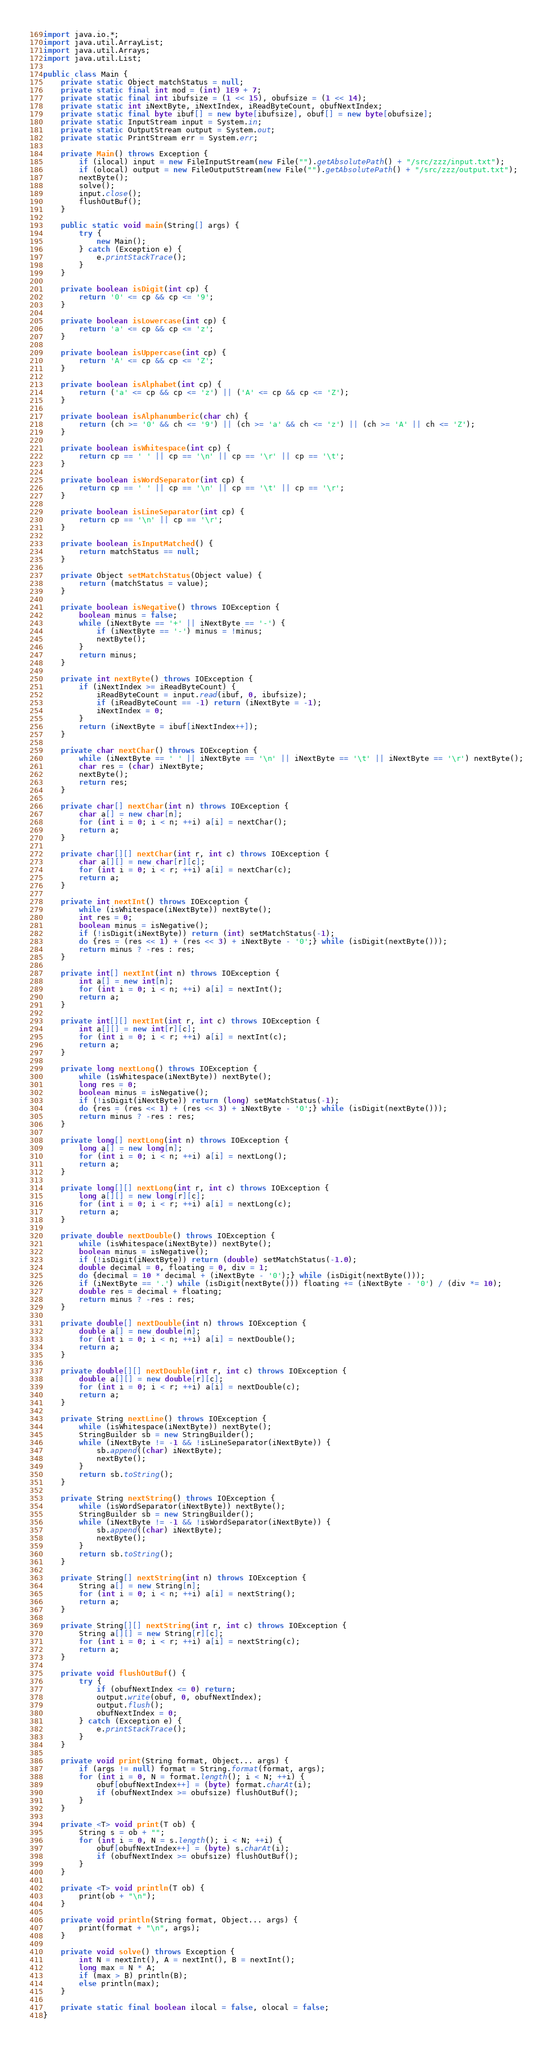<code> <loc_0><loc_0><loc_500><loc_500><_Java_>import java.io.*;
import java.util.ArrayList;
import java.util.Arrays;
import java.util.List;

public class Main {
	private static Object matchStatus = null;
	private static final int mod = (int) 1E9 + 7;
	private static final int ibufsize = (1 << 15), obufsize = (1 << 14);
	private static int iNextByte, iNextIndex, iReadByteCount, obufNextIndex;
	private static final byte ibuf[] = new byte[ibufsize], obuf[] = new byte[obufsize];
	private static InputStream input = System.in;
	private static OutputStream output = System.out;
	private static PrintStream err = System.err;

	private Main() throws Exception {
		if (ilocal) input = new FileInputStream(new File("").getAbsolutePath() + "/src/zzz/input.txt");
		if (olocal) output = new FileOutputStream(new File("").getAbsolutePath() + "/src/zzz/output.txt");
		nextByte();
		solve();
		input.close();
		flushOutBuf();
	}

	public static void main(String[] args) {
		try {
			new Main();
		} catch (Exception e) {
			e.printStackTrace();
		}
	}

	private boolean isDigit(int cp) {
		return '0' <= cp && cp <= '9';
	}

	private boolean isLowercase(int cp) {
		return 'a' <= cp && cp <= 'z';
	}

	private boolean isUppercase(int cp) {
		return 'A' <= cp && cp <= 'Z';
	}

	private boolean isAlphabet(int cp) {
		return ('a' <= cp && cp <= 'z') || ('A' <= cp && cp <= 'Z');
	}

	private boolean isAlphanumberic(char ch) {
		return (ch >= '0' && ch <= '9') || (ch >= 'a' && ch <= 'z') || (ch >= 'A' || ch <= 'Z');
	}

	private boolean isWhitespace(int cp) {
		return cp == ' ' || cp == '\n' || cp == '\r' || cp == '\t';
	}

	private boolean isWordSeparator(int cp) {
		return cp == ' ' || cp == '\n' || cp == '\t' || cp == '\r';
	}

	private boolean isLineSeparator(int cp) {
		return cp == '\n' || cp == '\r';
	}

	private boolean isInputMatched() {
		return matchStatus == null;
	}

	private Object setMatchStatus(Object value) {
		return (matchStatus = value);
	}

	private boolean isNegative() throws IOException {
		boolean minus = false;
		while (iNextByte == '+' || iNextByte == '-') {
			if (iNextByte == '-') minus = !minus;
			nextByte();
		}
		return minus;
	}

	private int nextByte() throws IOException {
		if (iNextIndex >= iReadByteCount) {
			iReadByteCount = input.read(ibuf, 0, ibufsize);
			if (iReadByteCount == -1) return (iNextByte = -1);
			iNextIndex = 0;
		}
		return (iNextByte = ibuf[iNextIndex++]);
	}

	private char nextChar() throws IOException {
		while (iNextByte == ' ' || iNextByte == '\n' || iNextByte == '\t' || iNextByte == '\r') nextByte();
		char res = (char) iNextByte;
		nextByte();
		return res;
	}

	private char[] nextChar(int n) throws IOException {
		char a[] = new char[n];
		for (int i = 0; i < n; ++i) a[i] = nextChar();
		return a;
	}

	private char[][] nextChar(int r, int c) throws IOException {
		char a[][] = new char[r][c];
		for (int i = 0; i < r; ++i) a[i] = nextChar(c);
		return a;
	}

	private int nextInt() throws IOException {
		while (isWhitespace(iNextByte)) nextByte();
		int res = 0;
		boolean minus = isNegative();
		if (!isDigit(iNextByte)) return (int) setMatchStatus(-1);
		do {res = (res << 1) + (res << 3) + iNextByte - '0';} while (isDigit(nextByte()));
		return minus ? -res : res;
	}

	private int[] nextInt(int n) throws IOException {
		int a[] = new int[n];
		for (int i = 0; i < n; ++i) a[i] = nextInt();
		return a;
	}

	private int[][] nextInt(int r, int c) throws IOException {
		int a[][] = new int[r][c];
		for (int i = 0; i < r; ++i) a[i] = nextInt(c);
		return a;
	}

	private long nextLong() throws IOException {
		while (isWhitespace(iNextByte)) nextByte();
		long res = 0;
		boolean minus = isNegative();
		if (!isDigit(iNextByte)) return (long) setMatchStatus(-1);
		do {res = (res << 1) + (res << 3) + iNextByte - '0';} while (isDigit(nextByte()));
		return minus ? -res : res;
	}

	private long[] nextLong(int n) throws IOException {
		long a[] = new long[n];
		for (int i = 0; i < n; ++i) a[i] = nextLong();
		return a;
	}

	private long[][] nextLong(int r, int c) throws IOException {
		long a[][] = new long[r][c];
		for (int i = 0; i < r; ++i) a[i] = nextLong(c);
		return a;
	}

	private double nextDouble() throws IOException {
		while (isWhitespace(iNextByte)) nextByte();
		boolean minus = isNegative();
		if (!isDigit(iNextByte)) return (double) setMatchStatus(-1.0);
		double decimal = 0, floating = 0, div = 1;
		do {decimal = 10 * decimal + (iNextByte - '0');} while (isDigit(nextByte()));
		if (iNextByte == '.') while (isDigit(nextByte())) floating += (iNextByte - '0') / (div *= 10);
		double res = decimal + floating;
		return minus ? -res : res;
	}

	private double[] nextDouble(int n) throws IOException {
		double a[] = new double[n];
		for (int i = 0; i < n; ++i) a[i] = nextDouble();
		return a;
	}

	private double[][] nextDouble(int r, int c) throws IOException {
		double a[][] = new double[r][c];
		for (int i = 0; i < r; ++i) a[i] = nextDouble(c);
		return a;
	}

	private String nextLine() throws IOException {
		while (isWhitespace(iNextByte)) nextByte();
		StringBuilder sb = new StringBuilder();
		while (iNextByte != -1 && !isLineSeparator(iNextByte)) {
			sb.append((char) iNextByte);
			nextByte();
		}
		return sb.toString();
	}

	private String nextString() throws IOException {
		while (isWordSeparator(iNextByte)) nextByte();
		StringBuilder sb = new StringBuilder();
		while (iNextByte != -1 && !isWordSeparator(iNextByte)) {
			sb.append((char) iNextByte);
			nextByte();
		}
		return sb.toString();
	}

	private String[] nextString(int n) throws IOException {
		String a[] = new String[n];
		for (int i = 0; i < n; ++i) a[i] = nextString();
		return a;
	}

	private String[][] nextString(int r, int c) throws IOException {
		String a[][] = new String[r][c];
		for (int i = 0; i < r; ++i) a[i] = nextString(c);
		return a;
	}

	private void flushOutBuf() {
		try {
			if (obufNextIndex <= 0) return;
			output.write(obuf, 0, obufNextIndex);
			output.flush();
			obufNextIndex = 0;
		} catch (Exception e) {
			e.printStackTrace();
		}
	}

	private void print(String format, Object... args) {
		if (args != null) format = String.format(format, args);
		for (int i = 0, N = format.length(); i < N; ++i) {
			obuf[obufNextIndex++] = (byte) format.charAt(i);
			if (obufNextIndex >= obufsize) flushOutBuf();
		}
	}

	private <T> void print(T ob) {
		String s = ob + "";
		for (int i = 0, N = s.length(); i < N; ++i) {
			obuf[obufNextIndex++] = (byte) s.charAt(i);
			if (obufNextIndex >= obufsize) flushOutBuf();
		}
	}

	private <T> void println(T ob) {
		print(ob + "\n");
	}

	private void println(String format, Object... args) {
		print(format + "\n", args);
	}

	private void solve() throws Exception {
		int N = nextInt(), A = nextInt(), B = nextInt();
		long max = N * A;
		if (max > B) println(B);
		else println(max);
	}

	private static final boolean ilocal = false, olocal = false;
}
</code> 